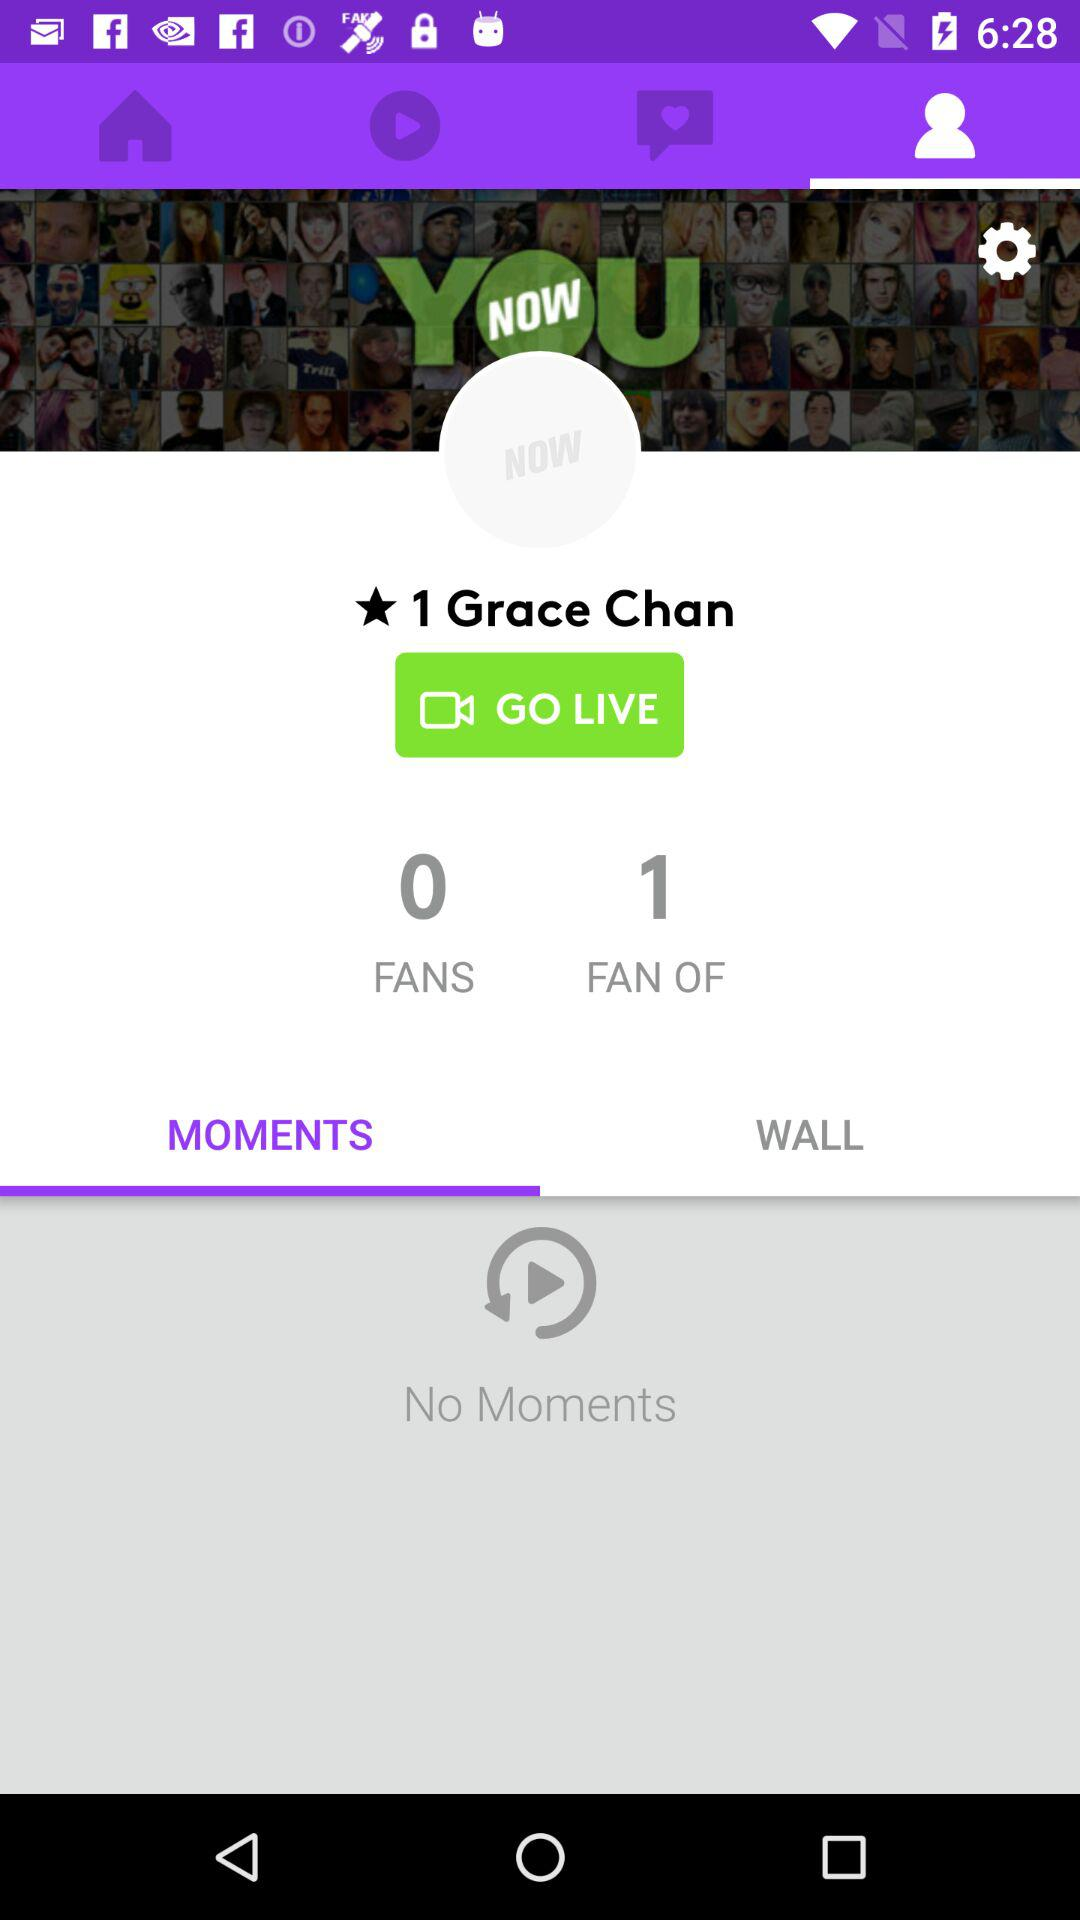What is the number of "FAN OF"? The number of "FAN OF" is 1. 